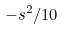Convert formula to latex. <formula><loc_0><loc_0><loc_500><loc_500>- s ^ { 2 } / 1 0</formula> 